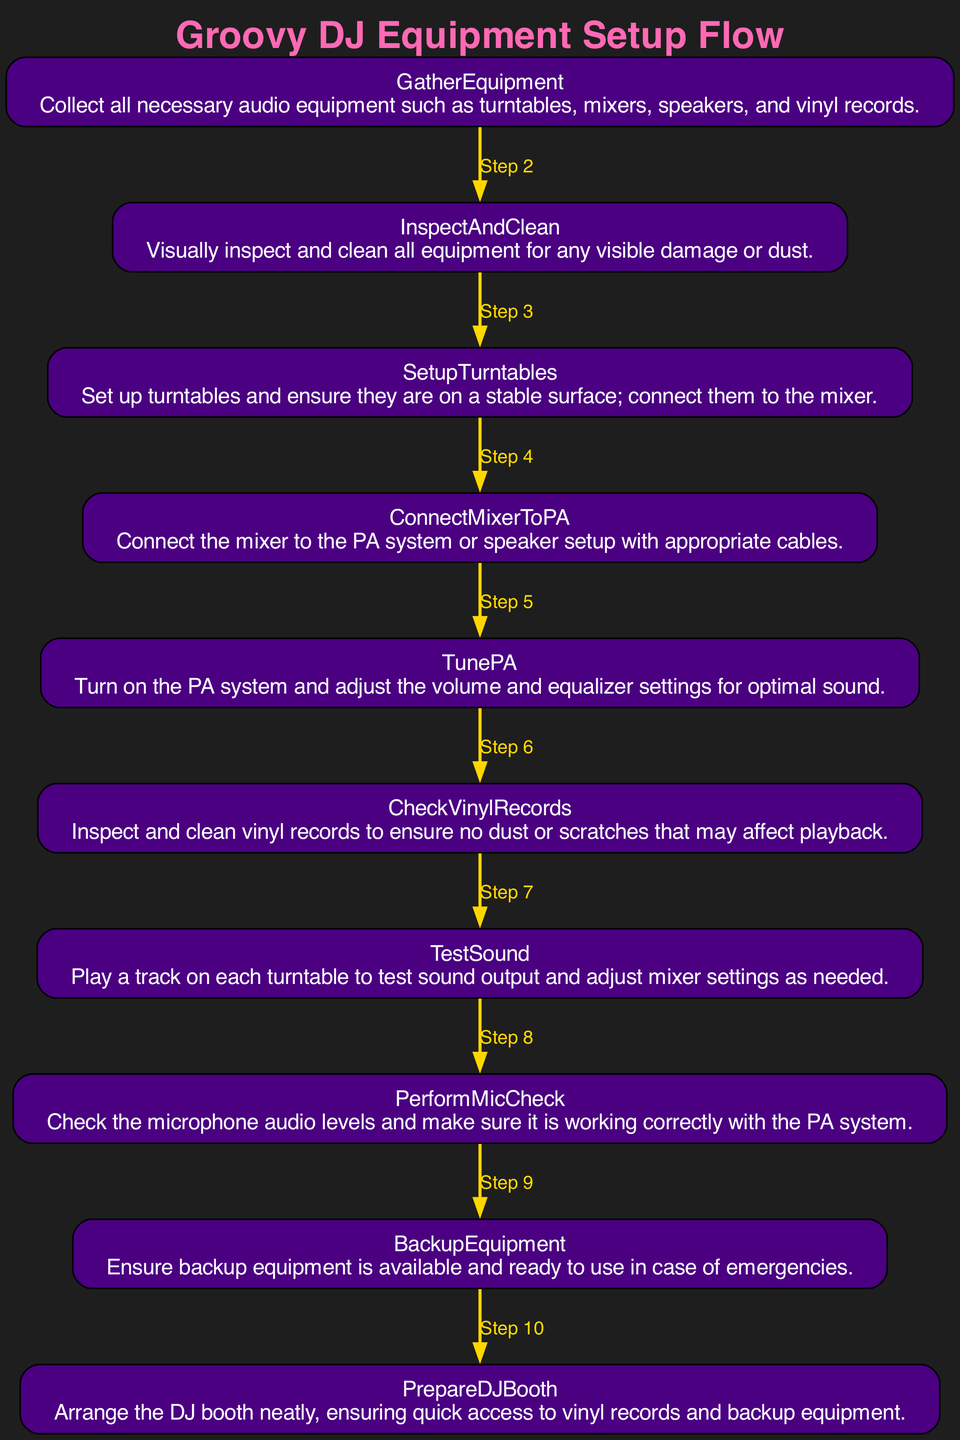What is the first step in the setup process? The first step listed in the flowchart is "GatherEquipment." It indicates that this is the starting point for the entire process of setting up audio equipment.
Answer: GatherEquipment How many total steps are there in the diagram? Counting all the nodes from the start to the end, there are ten steps in total, which are outlined sequentially in the flowchart.
Answer: Ten What step comes after "InspectAndClean"? The step that follows "InspectAndClean" is "SetupTurntables." This can be traced by moving through the flow of the diagram where each step leads to the next.
Answer: SetupTurntables Which step involves checking microphone levels? The step that specifically mentions checking microphone audio levels is "PerformMicCheck." It is clearly denoted in the sequence of actions depicted in the diagram.
Answer: PerformMicCheck Which two steps are directly connected by an edge? The steps "TunePA" and "TestSound" are directly connected. The flow from "TunePA" leads to "TestSound," showing the progression of actions in the setup.
Answer: TunePA and TestSound What is the last step before "PrepareDJBooth"? Before "PrepareDJBooth," the step is "BackupEquipment." This can be confirmed by following the flowchart from the start to the end.
Answer: BackupEquipment How does "ConnectMixerToPA" relate to the overall setup? "ConnectMixerToPA" is pivotal as it focuses on connecting the mixer to the PA system, ensuring sound can be amplified, crucial for any live DJ set. This indicates a dependency on proper mixer setup before moving forward.
Answer: It is pivotal What follows after testing sound on the turntables? After "TestSound," the next step in the flowchart is "PerformMicCheck." This shows the sequential nature of testing sound output followed by checking microphone functionality.
Answer: PerformMicCheck 